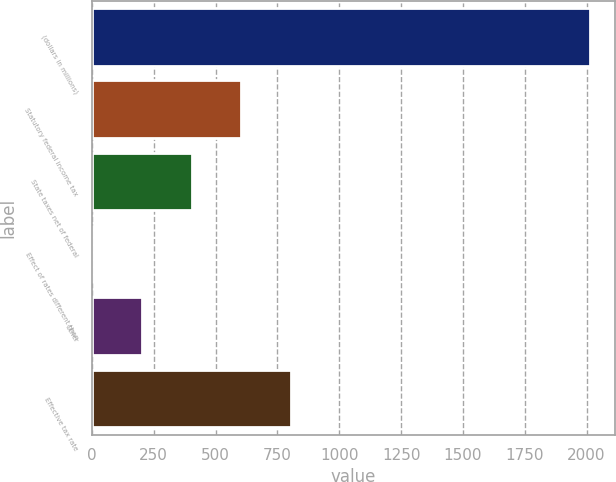Convert chart to OTSL. <chart><loc_0><loc_0><loc_500><loc_500><bar_chart><fcel>(dollars in millions)<fcel>Statutory federal income tax<fcel>State taxes net of federal<fcel>Effect of rates different than<fcel>Other<fcel>Effective tax rate<nl><fcel>2014<fcel>604.55<fcel>403.2<fcel>0.5<fcel>201.85<fcel>805.9<nl></chart> 